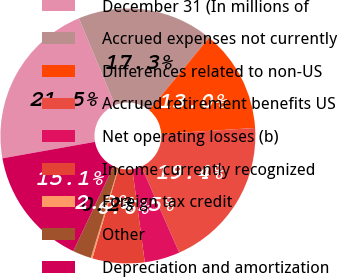Convert chart to OTSL. <chart><loc_0><loc_0><loc_500><loc_500><pie_chart><fcel>December 31 (In millions of<fcel>Accrued expenses not currently<fcel>Differences related to non-US<fcel>Accrued retirement benefits US<fcel>Net operating losses (b)<fcel>Income currently recognized<fcel>Foreign tax credit<fcel>Other<fcel>Depreciation and amortization<nl><fcel>21.53%<fcel>17.27%<fcel>13.01%<fcel>19.4%<fcel>4.48%<fcel>6.61%<fcel>0.21%<fcel>2.35%<fcel>15.14%<nl></chart> 